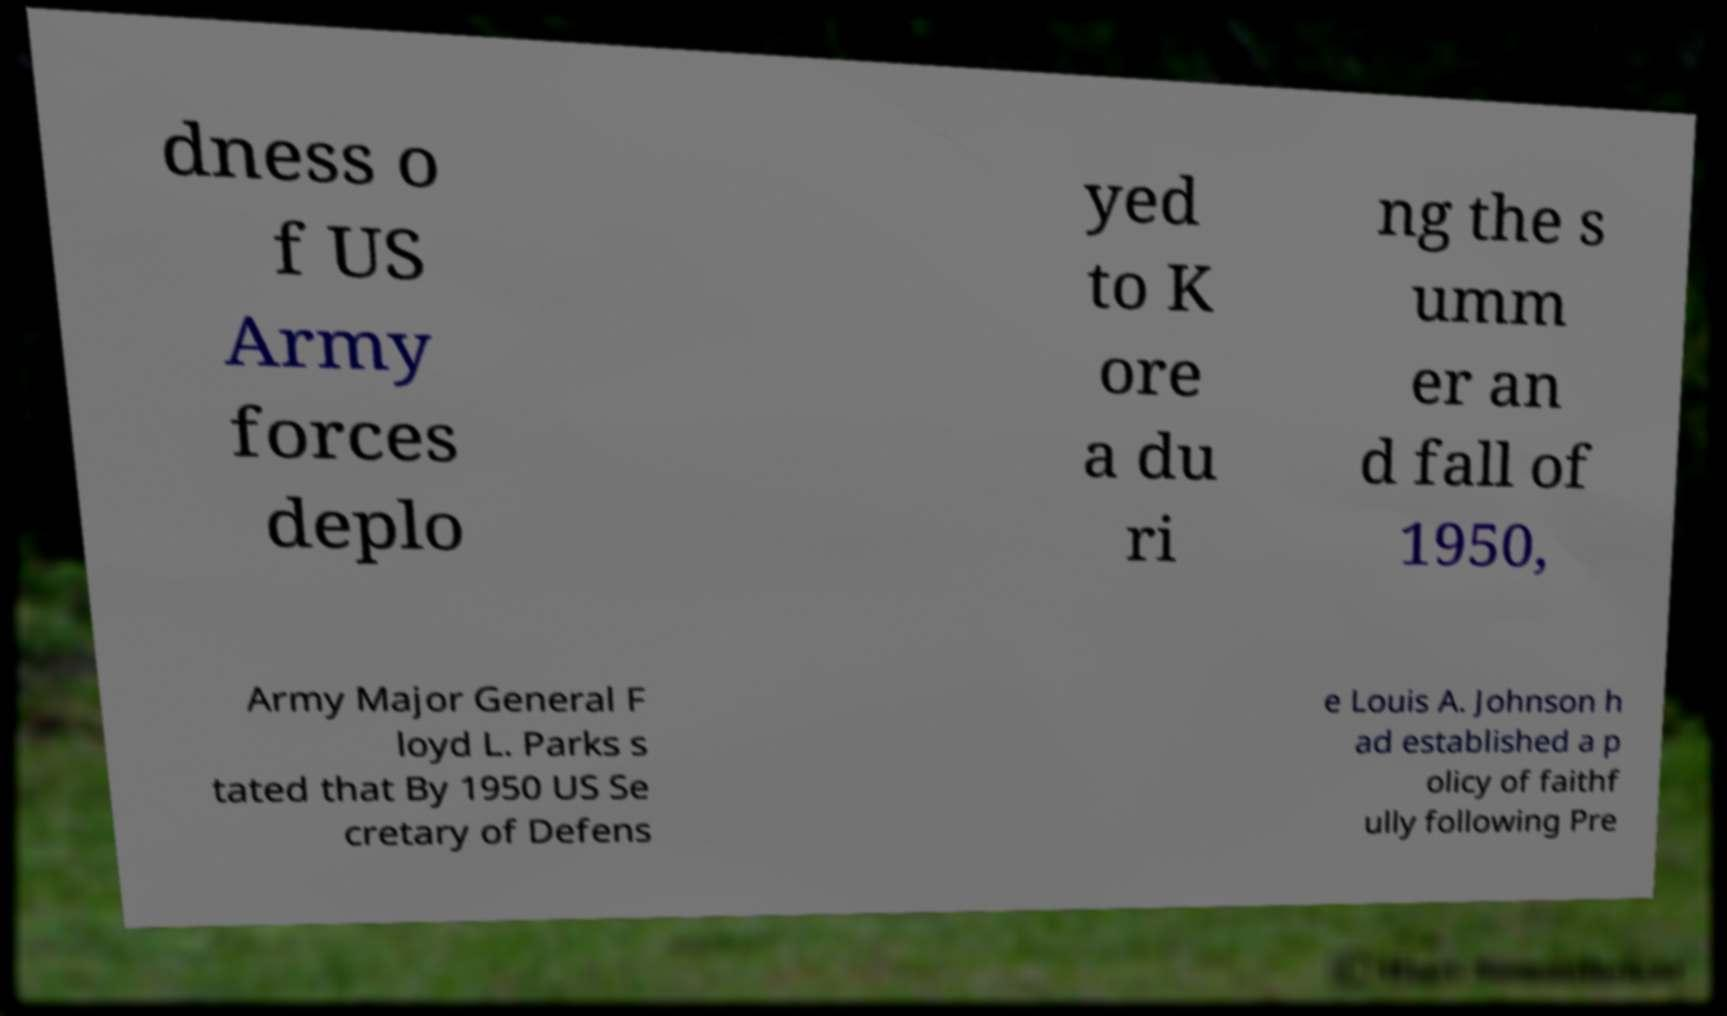Can you accurately transcribe the text from the provided image for me? dness o f US Army forces deplo yed to K ore a du ri ng the s umm er an d fall of 1950, Army Major General F loyd L. Parks s tated that By 1950 US Se cretary of Defens e Louis A. Johnson h ad established a p olicy of faithf ully following Pre 